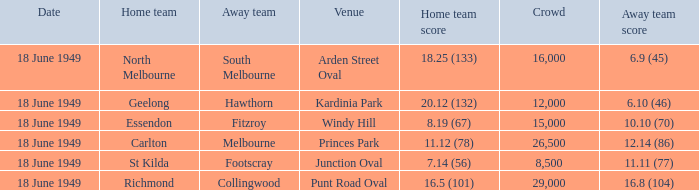What is the away team score when home team score is 20.12 (132)? 6.10 (46). 